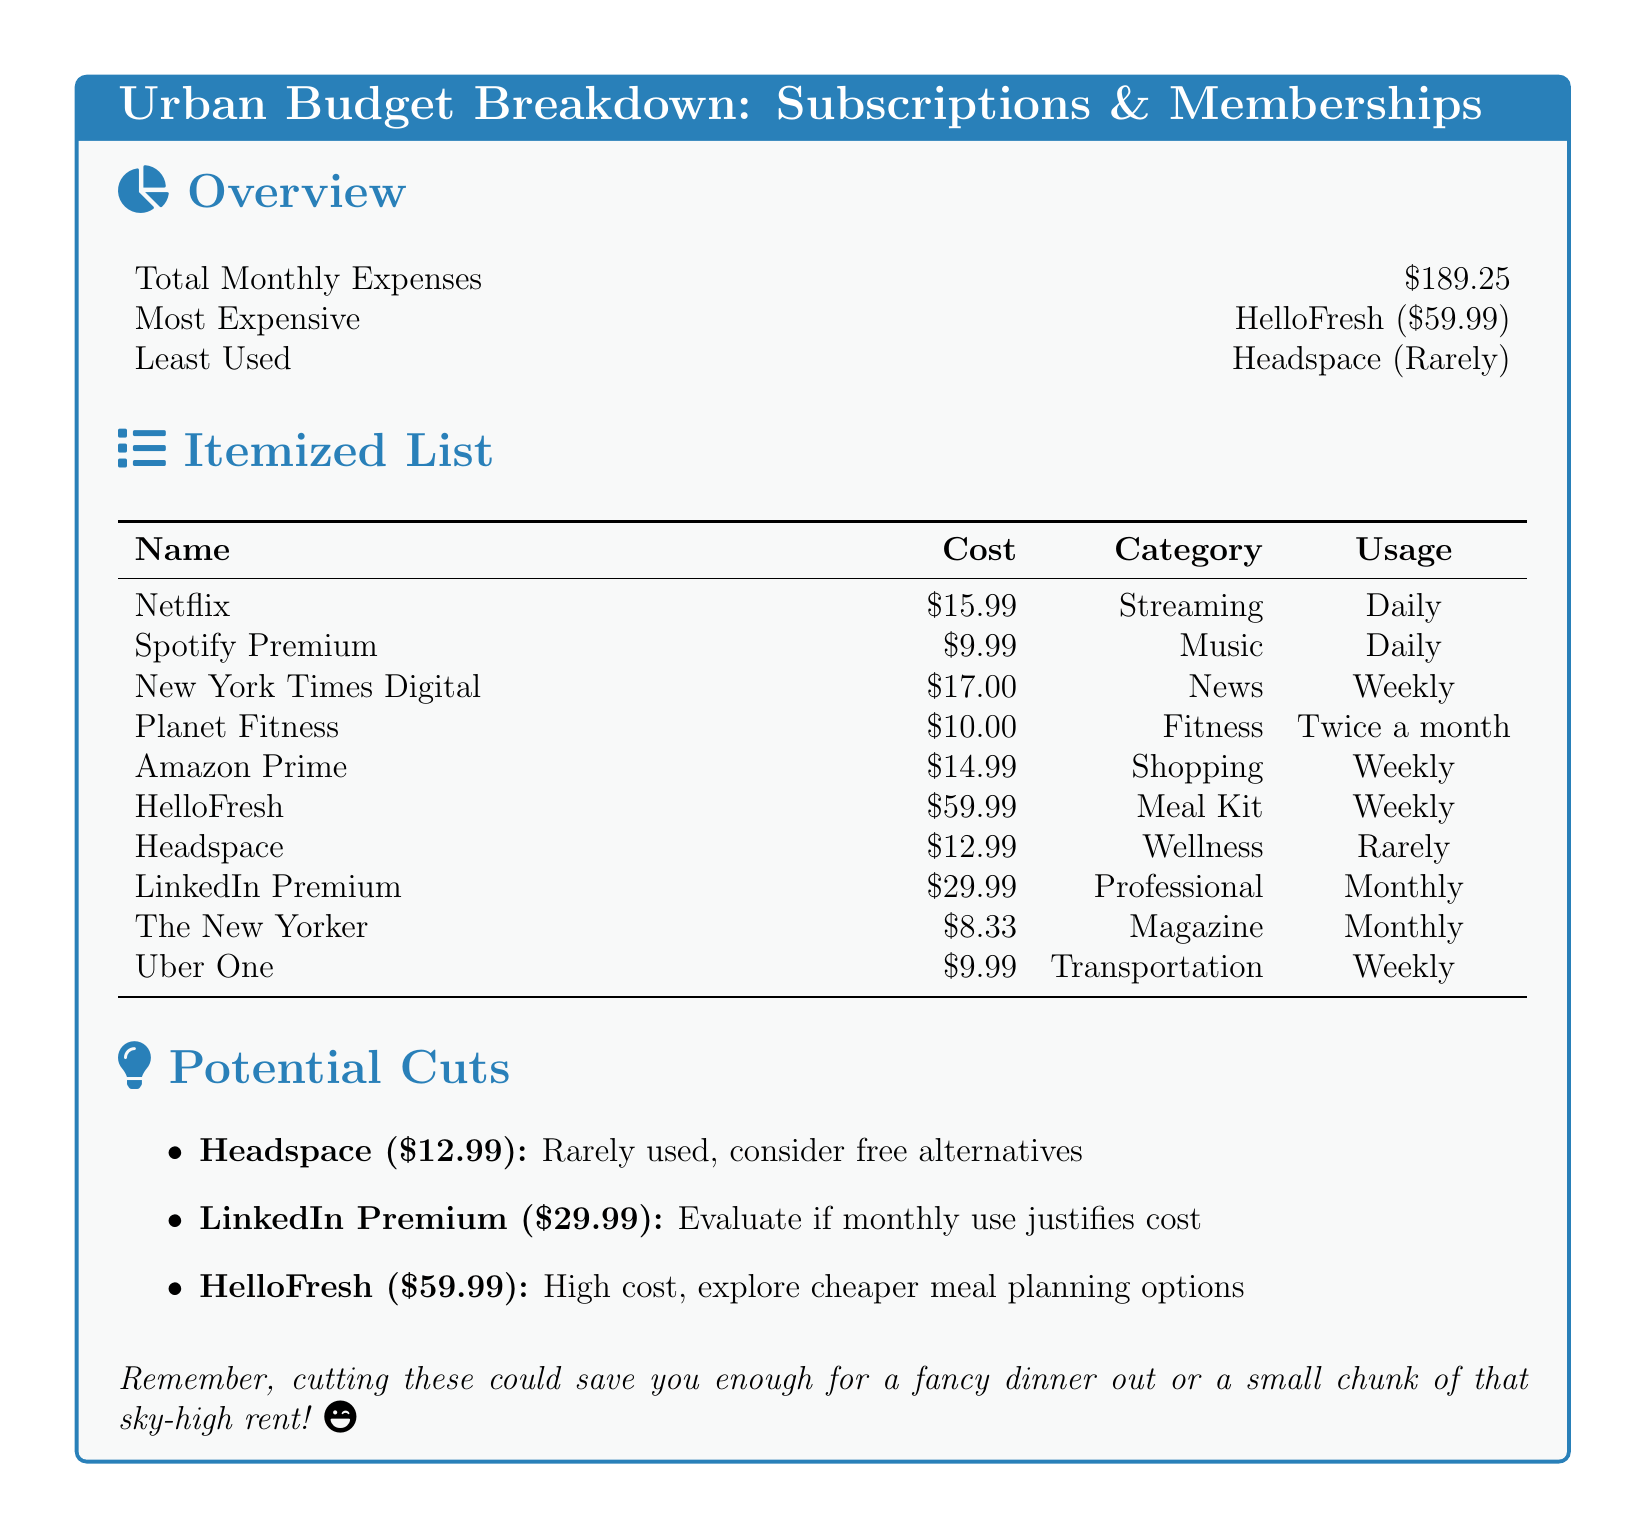What is the total monthly expense? The total monthly expense is listed at the beginning of the document and is \$189.25.
Answer: \$189.25 What is the most expensive subscription? The most expensive subscription is specified in the overview section as HelloFresh.
Answer: HelloFresh How often is Netflix used? The usage frequency of Netflix is mentioned in the itemized list as Daily.
Answer: Daily What is the cost of LinkedIn Premium? The cost for LinkedIn Premium is provided in the itemized list as \$29.99.
Answer: \$29.99 Which subscription is the least used? The least used subscription is noted in the overview section as Headspace.
Answer: Headspace How often is Planet Fitness used? The document indicates that Planet Fitness is used Twice a month.
Answer: Twice a month What is the potential cut suggestion for HelloFresh? The document suggests exploring cheaper meal planning options for HelloFresh.
Answer: Explore cheaper meal planning options What is the total cost of all weekly subscriptions? To calculate, we can add the costs of the three weekly subscriptions: New York Times Digital, Amazon Prime, and Uber One. Total is \$37.98.
Answer: \$37.98 What category does Spotify Premium belong to? The category for Spotify Premium is given in the itemized list as Music.
Answer: Music 